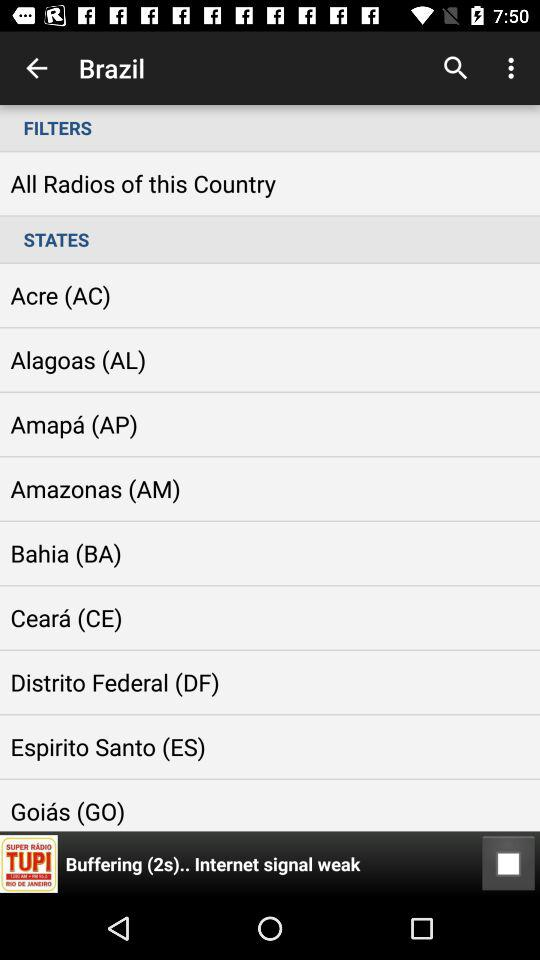How many seconds has the radio been buffering?
Answer the question using a single word or phrase. 2 